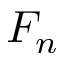<formula> <loc_0><loc_0><loc_500><loc_500>F _ { n }</formula> 